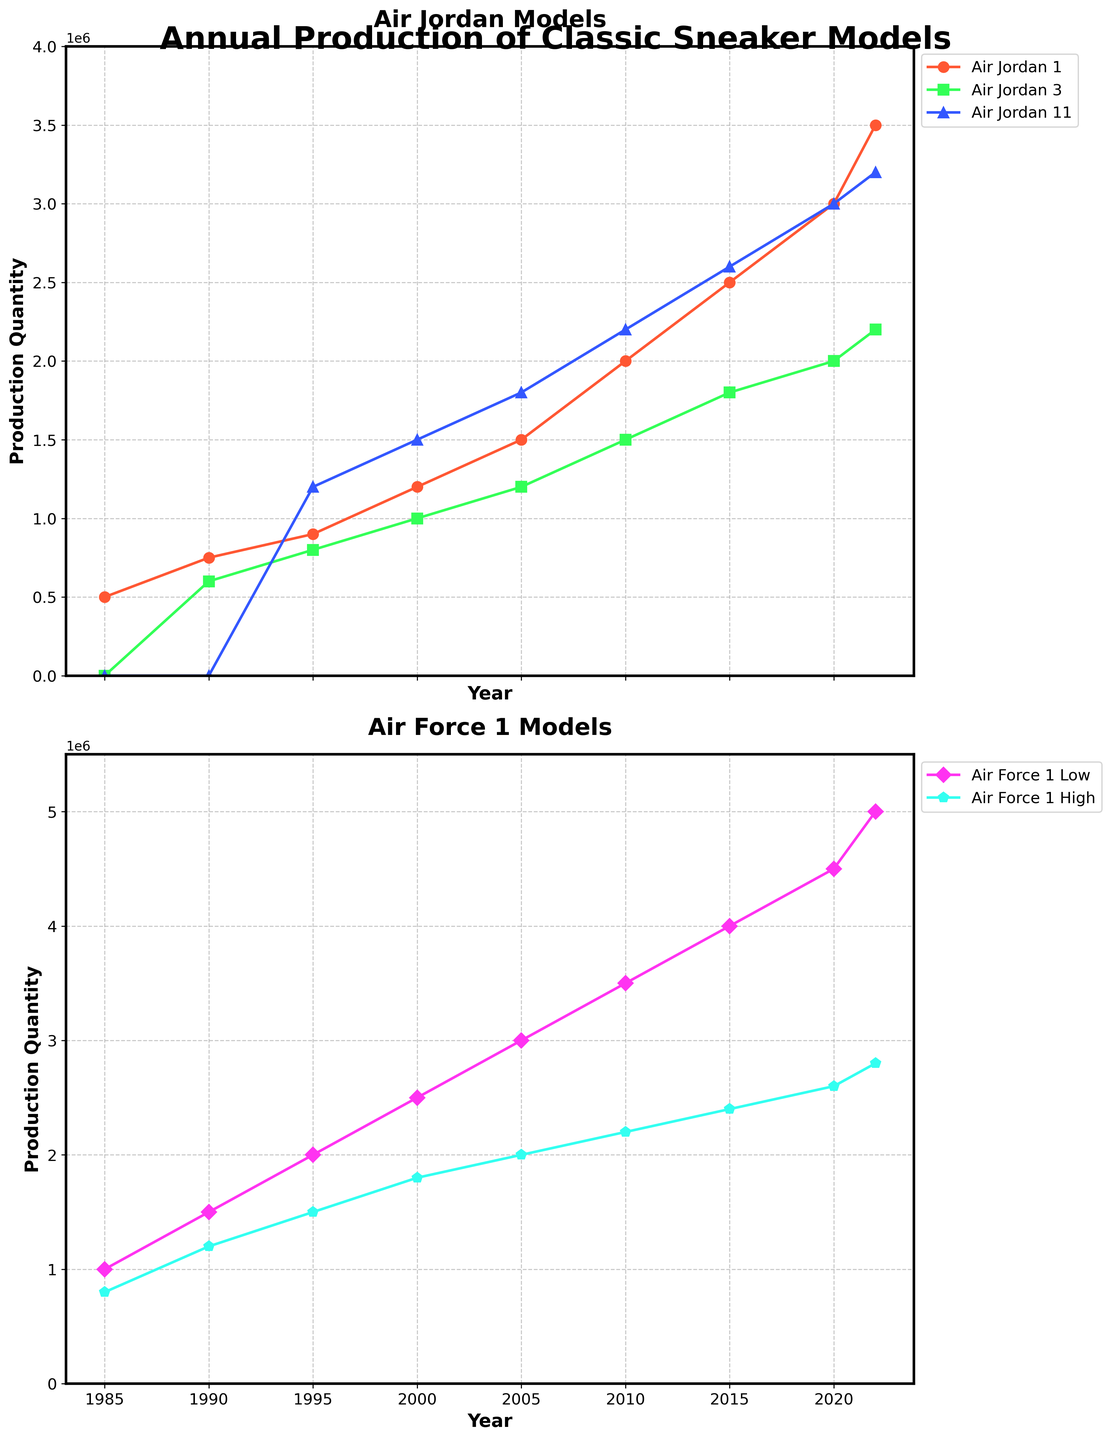What is the title of the figure? The title is usually shown at the top of the figure. In this case, it reads "Annual Production of Classic Sneaker Models."
Answer: Annual Production of Classic Sneaker Models Which model had the highest production in 2022? For 2022, observe all the lines to see which one has the highest value on the y-axis at this specific year. The Air Force 1 Low line peaks at 5,000,000.
Answer: Air Force 1 Low In what years did the production quantity of Air Jordan 1 exceed 2,000,000 units? Follow the Air Jordan 1 line and check its y-values. It exceeds 2,000,000 units in 2010, 2015, 2020, and 2022.
Answer: 2010, 2015, 2020, 2022 Which model shows the most significant increase in production quantity from 1985 to 2022? Calculate the difference between the values in 1985 and 2022 for each model, and the greatest difference indicates the most significant increase. Air Force 1 Low production increased from 1,000,000 in 1985 to 5,000,000 in 2022 (an increase of 4,000,000).
Answer: Air Force 1 Low What is the sum of production quantities for Air Jordan 11 and Air Force 1 High in 2000? Identify the production values for these models in 2000: Air Jordan 11 (1,500,000) and Air Force 1 High (1,800,000). Sum them up, 1,500,000 + 1,800,000 = 3,300,000.
Answer: 3,300,000 How do the production trends of Air Jordan 3 and Air Force 1 High compare over the years? Examine both lines in the figure. Both lines show an increasing trend from 1990 onwards, with Air Force 1 High generally having higher production quantities than Air Jordan 3.
Answer: Both show an increasing trend, with Air Force 1 High generally higher Which years did the production quantities of Air Jordan 11 surpass those of Air Jordan 3? Compare the lines for Air Jordan 11 and Air Jordan 3. Air Jordan 11 surpasses Air Jordan 3 in 1995, 2000, 2005, 2010, 2015, 2020, and 2022.
Answer: 1995, 2000, 2005, 2010, 2015, 2020, 2022 What is the average production quantity of Air Force 1 Low from 1985 to 2022? Sum all production quantities from 1985 to 2022 for Air Force 1 Low and divide by the number of years (9). (1,000,000 + 1,500,000 + 2,000,000 + 2,500,000 + 3,000,000 + 3,500,000 + 4,000,000 + 4,500,000 + 5,000,000) / 9 = 3,000,000.
Answer: 3,000,000 